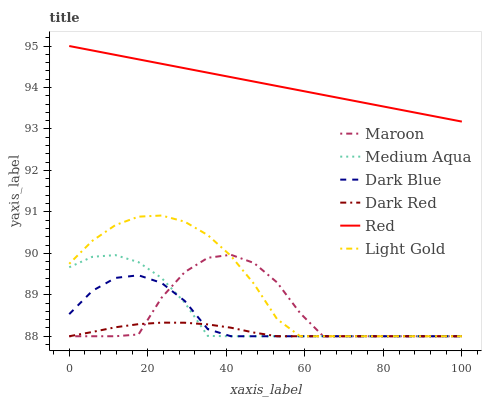Does Dark Red have the minimum area under the curve?
Answer yes or no. Yes. Does Red have the maximum area under the curve?
Answer yes or no. Yes. Does Maroon have the minimum area under the curve?
Answer yes or no. No. Does Maroon have the maximum area under the curve?
Answer yes or no. No. Is Red the smoothest?
Answer yes or no. Yes. Is Maroon the roughest?
Answer yes or no. Yes. Is Dark Blue the smoothest?
Answer yes or no. No. Is Dark Blue the roughest?
Answer yes or no. No. Does Dark Red have the lowest value?
Answer yes or no. Yes. Does Red have the lowest value?
Answer yes or no. No. Does Red have the highest value?
Answer yes or no. Yes. Does Maroon have the highest value?
Answer yes or no. No. Is Medium Aqua less than Red?
Answer yes or no. Yes. Is Red greater than Light Gold?
Answer yes or no. Yes. Does Medium Aqua intersect Maroon?
Answer yes or no. Yes. Is Medium Aqua less than Maroon?
Answer yes or no. No. Is Medium Aqua greater than Maroon?
Answer yes or no. No. Does Medium Aqua intersect Red?
Answer yes or no. No. 